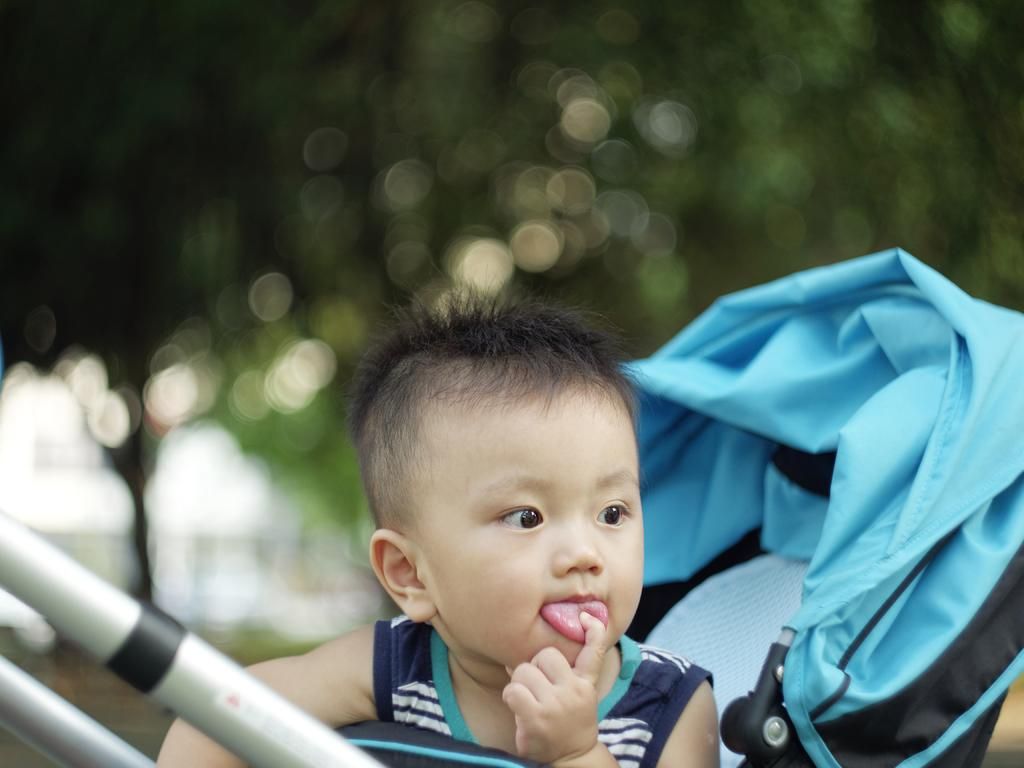What is the main subject in the foreground of the picture? There is a kid in the foreground of the picture. What is the kid's mode of transportation in the image? The kid is in a stroller. What type of environment can be seen in the background of the image? There is greenery in the background of the image. Can you see a giraffe in the background of the image? No, there is no giraffe present in the image. Is the kid's grandmother pushing the stroller in the image? The provided facts do not mention the presence of a grandmother, so it cannot be determined from the image. 